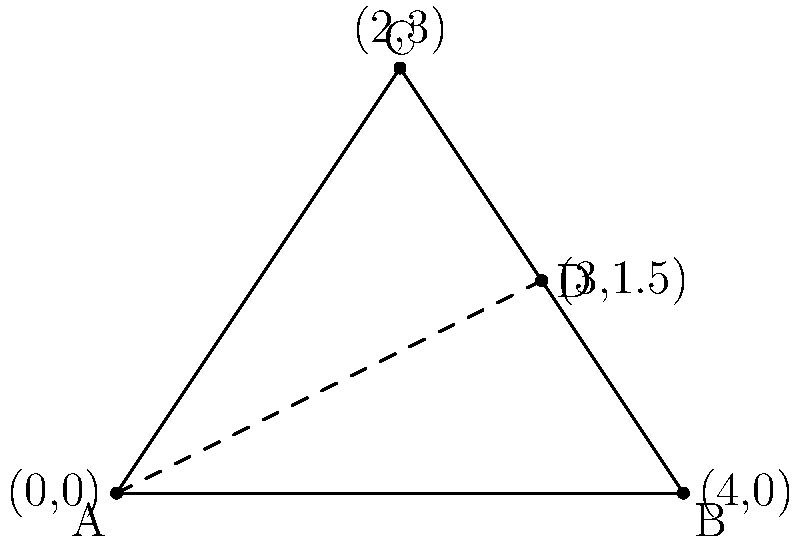In the ziggurat of Ur, archaeologists discovered a triangular stone tablet depicting a geometric pattern similar to the one shown above. If the length of side BC is 10 cubits and AD is a median, what is the area of triangle ABD in square cubits? Let's approach this step-by-step:

1) In the triangle ABC, AD is a median, which means D is the midpoint of BC.

2) Given that BC = 10 cubits, BD = DC = 5 cubits.

3) The area of triangle ABD can be calculated using the formula: 
   $$Area = \frac{1}{2} \times base \times height$$

4) We know the base (BD = 5 cubits), but we need to find the height (perpendicular from A to BD).

5) To find this height, we can use the property that the median divides the triangle into two equal areas. This means:
   $$Area_{ABD} = \frac{1}{2} \times Area_{ABC}$$

6) We can find the area of ABC using Heron's formula:
   $$s = \frac{a + b + c}{2}$$
   $$Area = \sqrt{s(s-a)(s-b)(s-c)}$$
   where a, b, c are the sides of the triangle.

7) We only know BC = 10. Let's assume AB = c and AC = b. The semi-perimeter s = (10 + b + c)/2.

8) The area of ABC is then:
   $$Area_{ABC} = \sqrt{\frac{10 + b + c}{2} \times \frac{b + c - 10}{2} \times \frac{c + 10 - b}{2} \times \frac{10 + b - c}{2}}$$

9) The area of ABD is half of this:
   $$Area_{ABD} = \frac{1}{2} \times \sqrt{\frac{10 + b + c}{2} \times \frac{b + c - 10}{2} \times \frac{c + 10 - b}{2} \times \frac{10 + b - c}{2}}$$

10) This can be simplified to:
    $$Area_{ABD} = \frac{1}{4} \times \sqrt{(10 + b + c)(b + c - 10)(c + 10 - b)(10 + b - c)}$$

11) While we don't know the exact values of b and c, this expression represents the area of triangle ABD in square cubits.
Answer: $\frac{1}{4} \times \sqrt{(10 + b + c)(b + c - 10)(c + 10 - b)(10 + b - c)}$ square cubits 